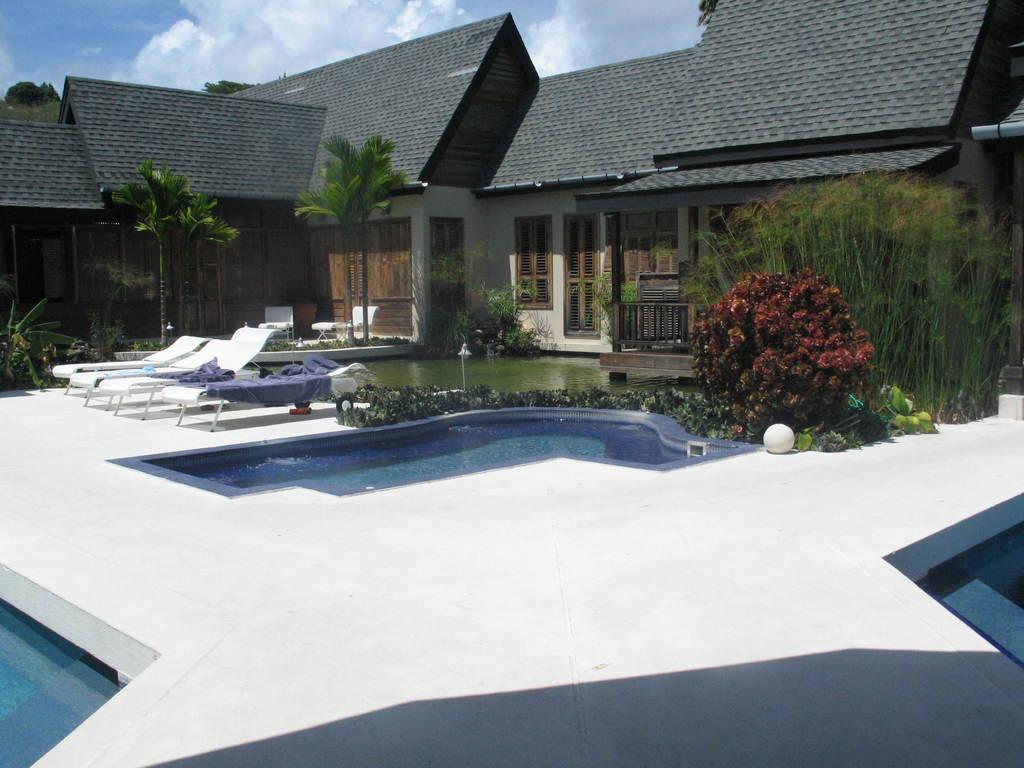How would you summarize this image in a sentence or two? In this image I can see three swimming pools in the front. In the background I can see number of plants, trees, a building, few chairs, clothes,few poles, few lights and I can also see water in the front of the building. On the top side of this image I can see clouds and the sky. 